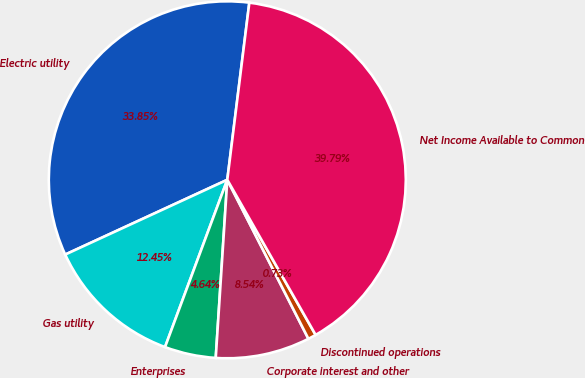Convert chart to OTSL. <chart><loc_0><loc_0><loc_500><loc_500><pie_chart><fcel>Electric utility<fcel>Gas utility<fcel>Enterprises<fcel>Corporate interest and other<fcel>Discontinued operations<fcel>Net Income Available to Common<nl><fcel>33.85%<fcel>12.45%<fcel>4.64%<fcel>8.54%<fcel>0.73%<fcel>39.79%<nl></chart> 